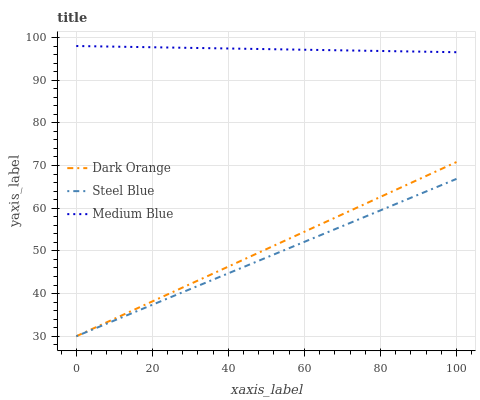Does Medium Blue have the minimum area under the curve?
Answer yes or no. No. Does Steel Blue have the maximum area under the curve?
Answer yes or no. No. Is Steel Blue the smoothest?
Answer yes or no. No. Is Steel Blue the roughest?
Answer yes or no. No. Does Medium Blue have the lowest value?
Answer yes or no. No. Does Steel Blue have the highest value?
Answer yes or no. No. Is Dark Orange less than Medium Blue?
Answer yes or no. Yes. Is Medium Blue greater than Steel Blue?
Answer yes or no. Yes. Does Dark Orange intersect Medium Blue?
Answer yes or no. No. 